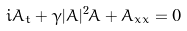<formula> <loc_0><loc_0><loc_500><loc_500>i A _ { t } + \gamma | A | ^ { 2 } A + A _ { x x } = 0</formula> 